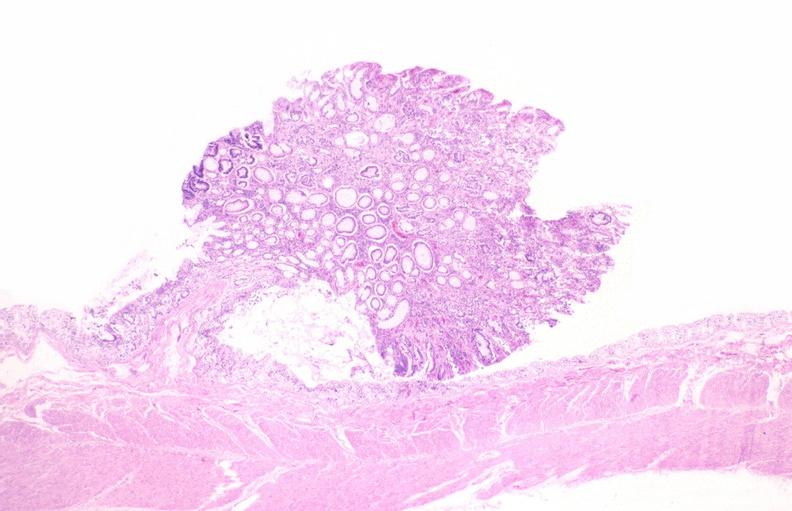what is present?
Answer the question using a single word or phrase. Gastrointestinal 